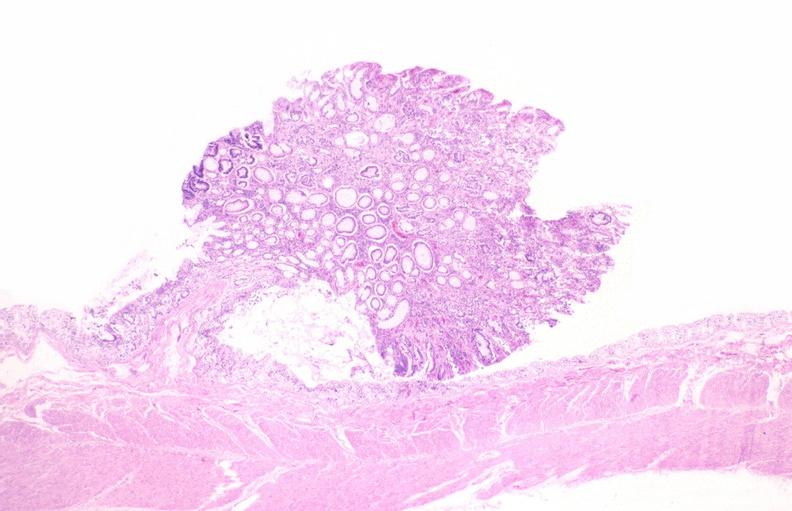what is present?
Answer the question using a single word or phrase. Gastrointestinal 